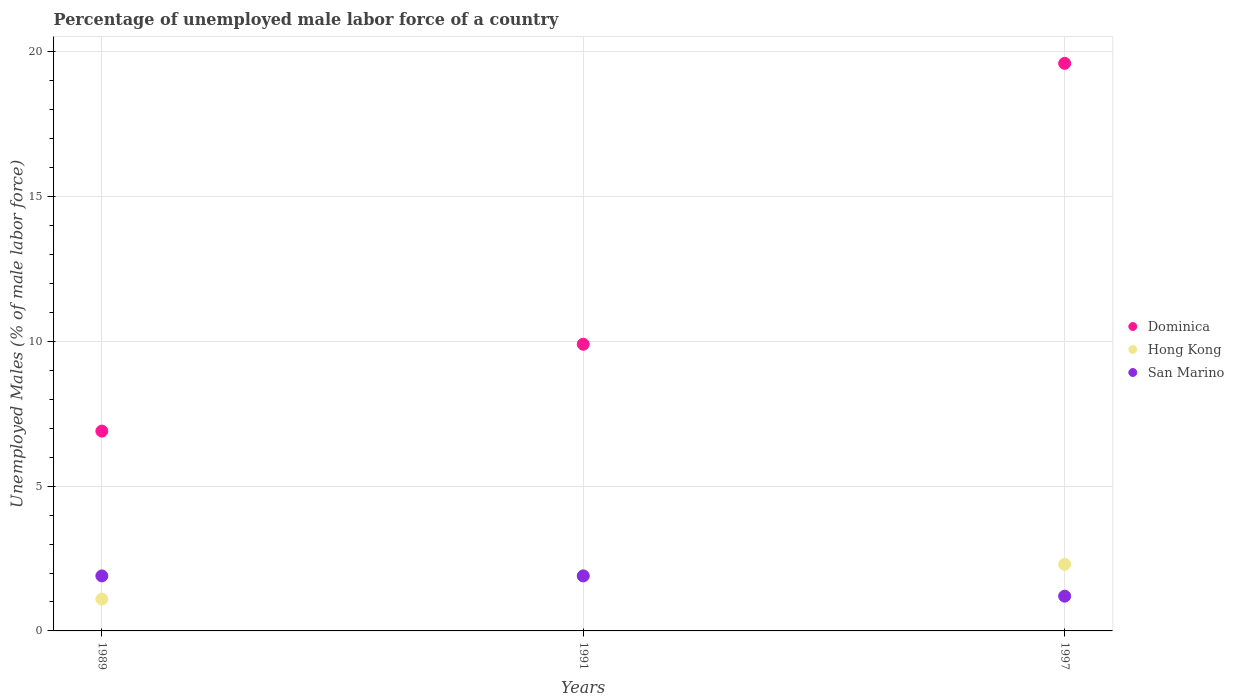How many different coloured dotlines are there?
Your answer should be very brief. 3. Is the number of dotlines equal to the number of legend labels?
Give a very brief answer. Yes. What is the percentage of unemployed male labor force in Dominica in 1997?
Give a very brief answer. 19.6. Across all years, what is the maximum percentage of unemployed male labor force in Dominica?
Keep it short and to the point. 19.6. Across all years, what is the minimum percentage of unemployed male labor force in Dominica?
Your answer should be compact. 6.9. What is the total percentage of unemployed male labor force in San Marino in the graph?
Provide a succinct answer. 5. What is the difference between the percentage of unemployed male labor force in San Marino in 1989 and that in 1991?
Offer a terse response. 0. What is the difference between the percentage of unemployed male labor force in Hong Kong in 1991 and the percentage of unemployed male labor force in Dominica in 1989?
Your answer should be very brief. -5. What is the average percentage of unemployed male labor force in Hong Kong per year?
Provide a succinct answer. 1.77. In the year 1989, what is the difference between the percentage of unemployed male labor force in Dominica and percentage of unemployed male labor force in Hong Kong?
Offer a very short reply. 5.8. Is the percentage of unemployed male labor force in Dominica in 1991 less than that in 1997?
Your response must be concise. Yes. Is the difference between the percentage of unemployed male labor force in Dominica in 1989 and 1991 greater than the difference between the percentage of unemployed male labor force in Hong Kong in 1989 and 1991?
Provide a succinct answer. No. What is the difference between the highest and the second highest percentage of unemployed male labor force in Dominica?
Make the answer very short. 9.7. What is the difference between the highest and the lowest percentage of unemployed male labor force in Dominica?
Make the answer very short. 12.7. Does the percentage of unemployed male labor force in Hong Kong monotonically increase over the years?
Offer a terse response. Yes. Is the percentage of unemployed male labor force in Dominica strictly less than the percentage of unemployed male labor force in San Marino over the years?
Keep it short and to the point. No. How many dotlines are there?
Give a very brief answer. 3. What is the difference between two consecutive major ticks on the Y-axis?
Provide a succinct answer. 5. Does the graph contain any zero values?
Make the answer very short. No. Where does the legend appear in the graph?
Offer a very short reply. Center right. What is the title of the graph?
Make the answer very short. Percentage of unemployed male labor force of a country. What is the label or title of the Y-axis?
Ensure brevity in your answer.  Unemployed Males (% of male labor force). What is the Unemployed Males (% of male labor force) in Dominica in 1989?
Provide a short and direct response. 6.9. What is the Unemployed Males (% of male labor force) of Hong Kong in 1989?
Your answer should be compact. 1.1. What is the Unemployed Males (% of male labor force) in San Marino in 1989?
Provide a short and direct response. 1.9. What is the Unemployed Males (% of male labor force) in Dominica in 1991?
Offer a very short reply. 9.9. What is the Unemployed Males (% of male labor force) of Hong Kong in 1991?
Make the answer very short. 1.9. What is the Unemployed Males (% of male labor force) in San Marino in 1991?
Offer a very short reply. 1.9. What is the Unemployed Males (% of male labor force) in Dominica in 1997?
Make the answer very short. 19.6. What is the Unemployed Males (% of male labor force) in Hong Kong in 1997?
Keep it short and to the point. 2.3. What is the Unemployed Males (% of male labor force) in San Marino in 1997?
Make the answer very short. 1.2. Across all years, what is the maximum Unemployed Males (% of male labor force) of Dominica?
Provide a succinct answer. 19.6. Across all years, what is the maximum Unemployed Males (% of male labor force) in Hong Kong?
Offer a terse response. 2.3. Across all years, what is the maximum Unemployed Males (% of male labor force) of San Marino?
Ensure brevity in your answer.  1.9. Across all years, what is the minimum Unemployed Males (% of male labor force) in Dominica?
Provide a short and direct response. 6.9. Across all years, what is the minimum Unemployed Males (% of male labor force) in Hong Kong?
Your response must be concise. 1.1. Across all years, what is the minimum Unemployed Males (% of male labor force) of San Marino?
Ensure brevity in your answer.  1.2. What is the total Unemployed Males (% of male labor force) of Dominica in the graph?
Your response must be concise. 36.4. What is the total Unemployed Males (% of male labor force) in San Marino in the graph?
Your answer should be compact. 5. What is the difference between the Unemployed Males (% of male labor force) in Dominica in 1989 and that in 1991?
Keep it short and to the point. -3. What is the difference between the Unemployed Males (% of male labor force) in San Marino in 1989 and that in 1991?
Your answer should be very brief. 0. What is the difference between the Unemployed Males (% of male labor force) of Hong Kong in 1989 and that in 1997?
Offer a terse response. -1.2. What is the difference between the Unemployed Males (% of male labor force) in Dominica in 1989 and the Unemployed Males (% of male labor force) in Hong Kong in 1991?
Make the answer very short. 5. What is the difference between the Unemployed Males (% of male labor force) in Dominica in 1989 and the Unemployed Males (% of male labor force) in San Marino in 1991?
Give a very brief answer. 5. What is the difference between the Unemployed Males (% of male labor force) in Dominica in 1991 and the Unemployed Males (% of male labor force) in Hong Kong in 1997?
Ensure brevity in your answer.  7.6. What is the difference between the Unemployed Males (% of male labor force) in Dominica in 1991 and the Unemployed Males (% of male labor force) in San Marino in 1997?
Offer a very short reply. 8.7. What is the difference between the Unemployed Males (% of male labor force) in Hong Kong in 1991 and the Unemployed Males (% of male labor force) in San Marino in 1997?
Keep it short and to the point. 0.7. What is the average Unemployed Males (% of male labor force) in Dominica per year?
Offer a terse response. 12.13. What is the average Unemployed Males (% of male labor force) in Hong Kong per year?
Offer a very short reply. 1.77. What is the average Unemployed Males (% of male labor force) in San Marino per year?
Offer a very short reply. 1.67. In the year 1989, what is the difference between the Unemployed Males (% of male labor force) of Dominica and Unemployed Males (% of male labor force) of Hong Kong?
Provide a succinct answer. 5.8. In the year 1991, what is the difference between the Unemployed Males (% of male labor force) in Dominica and Unemployed Males (% of male labor force) in Hong Kong?
Make the answer very short. 8. In the year 1991, what is the difference between the Unemployed Males (% of male labor force) of Dominica and Unemployed Males (% of male labor force) of San Marino?
Keep it short and to the point. 8. In the year 1997, what is the difference between the Unemployed Males (% of male labor force) in Dominica and Unemployed Males (% of male labor force) in San Marino?
Keep it short and to the point. 18.4. In the year 1997, what is the difference between the Unemployed Males (% of male labor force) of Hong Kong and Unemployed Males (% of male labor force) of San Marino?
Provide a short and direct response. 1.1. What is the ratio of the Unemployed Males (% of male labor force) in Dominica in 1989 to that in 1991?
Keep it short and to the point. 0.7. What is the ratio of the Unemployed Males (% of male labor force) in Hong Kong in 1989 to that in 1991?
Your response must be concise. 0.58. What is the ratio of the Unemployed Males (% of male labor force) in Dominica in 1989 to that in 1997?
Make the answer very short. 0.35. What is the ratio of the Unemployed Males (% of male labor force) of Hong Kong in 1989 to that in 1997?
Your answer should be compact. 0.48. What is the ratio of the Unemployed Males (% of male labor force) in San Marino in 1989 to that in 1997?
Offer a very short reply. 1.58. What is the ratio of the Unemployed Males (% of male labor force) of Dominica in 1991 to that in 1997?
Keep it short and to the point. 0.51. What is the ratio of the Unemployed Males (% of male labor force) in Hong Kong in 1991 to that in 1997?
Ensure brevity in your answer.  0.83. What is the ratio of the Unemployed Males (% of male labor force) in San Marino in 1991 to that in 1997?
Provide a succinct answer. 1.58. What is the difference between the highest and the second highest Unemployed Males (% of male labor force) of Dominica?
Make the answer very short. 9.7. What is the difference between the highest and the second highest Unemployed Males (% of male labor force) of Hong Kong?
Make the answer very short. 0.4. What is the difference between the highest and the second highest Unemployed Males (% of male labor force) of San Marino?
Ensure brevity in your answer.  0. What is the difference between the highest and the lowest Unemployed Males (% of male labor force) in Dominica?
Give a very brief answer. 12.7. What is the difference between the highest and the lowest Unemployed Males (% of male labor force) of Hong Kong?
Your answer should be compact. 1.2. What is the difference between the highest and the lowest Unemployed Males (% of male labor force) of San Marino?
Offer a very short reply. 0.7. 